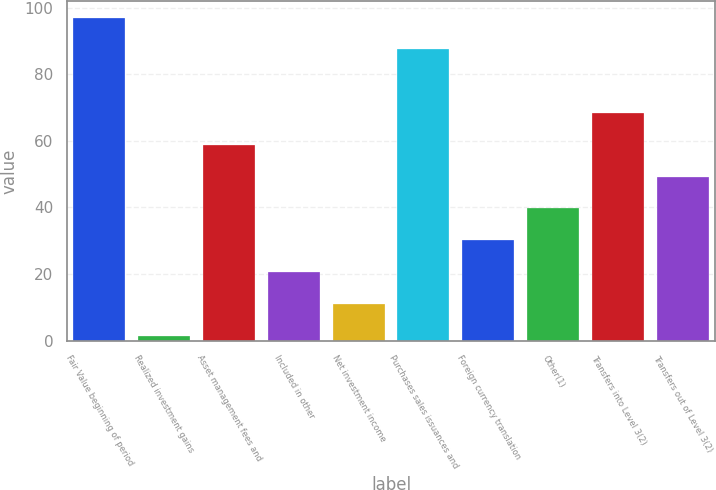Convert chart. <chart><loc_0><loc_0><loc_500><loc_500><bar_chart><fcel>Fair Value beginning of period<fcel>Realized investment gains<fcel>Asset management fees and<fcel>Included in other<fcel>Net investment income<fcel>Purchases sales issuances and<fcel>Foreign currency translation<fcel>Other(1)<fcel>Transfers into Level 3(2)<fcel>Transfers out of Level 3(2)<nl><fcel>97.04<fcel>1.44<fcel>58.8<fcel>20.56<fcel>11<fcel>87.48<fcel>30.12<fcel>39.68<fcel>68.36<fcel>49.24<nl></chart> 